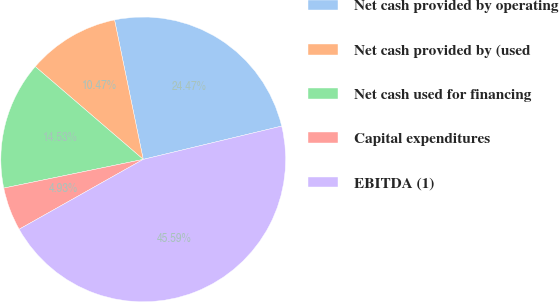Convert chart. <chart><loc_0><loc_0><loc_500><loc_500><pie_chart><fcel>Net cash provided by operating<fcel>Net cash provided by (used<fcel>Net cash used for financing<fcel>Capital expenditures<fcel>EBITDA (1)<nl><fcel>24.47%<fcel>10.47%<fcel>14.53%<fcel>4.93%<fcel>45.59%<nl></chart> 